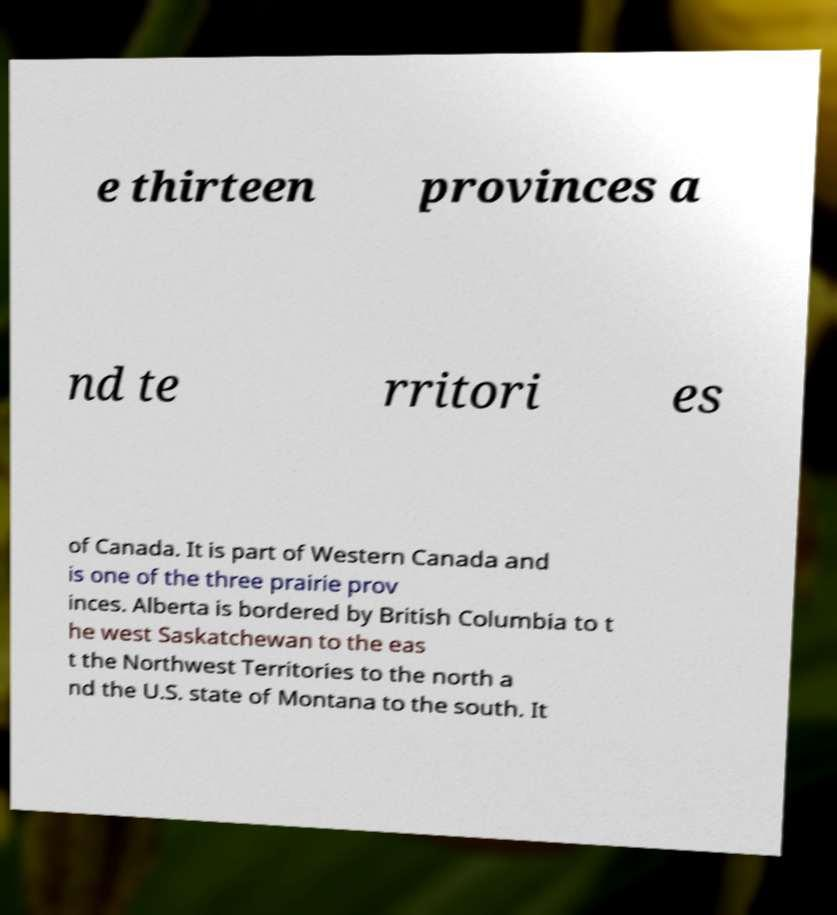Could you extract and type out the text from this image? e thirteen provinces a nd te rritori es of Canada. It is part of Western Canada and is one of the three prairie prov inces. Alberta is bordered by British Columbia to t he west Saskatchewan to the eas t the Northwest Territories to the north a nd the U.S. state of Montana to the south. It 